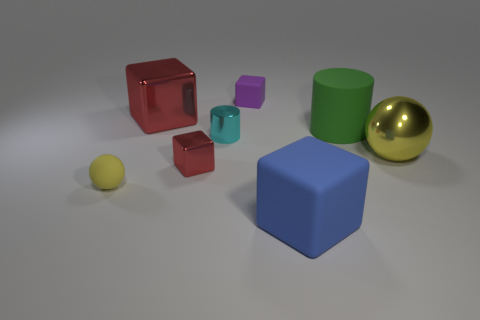Subtract 1 cubes. How many cubes are left? 3 Add 1 blue things. How many objects exist? 9 Subtract all cylinders. How many objects are left? 6 Add 4 blue matte cylinders. How many blue matte cylinders exist? 4 Subtract 0 green cubes. How many objects are left? 8 Subtract all tiny shiny objects. Subtract all big yellow metal things. How many objects are left? 5 Add 8 blue rubber blocks. How many blue rubber blocks are left? 9 